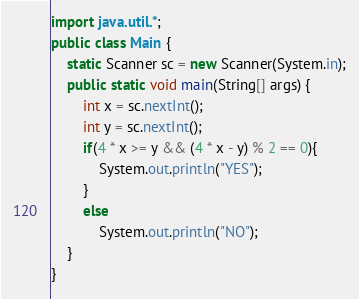Convert code to text. <code><loc_0><loc_0><loc_500><loc_500><_Java_>import java.util.*;
public class Main {
    static Scanner sc = new Scanner(System.in);
    public static void main(String[] args) {
        int x = sc.nextInt();
        int y = sc.nextInt();
        if(4 * x >= y && (4 * x - y) % 2 == 0){
            System.out.println("YES");
        }
        else
            System.out.println("NO");
    }
}</code> 